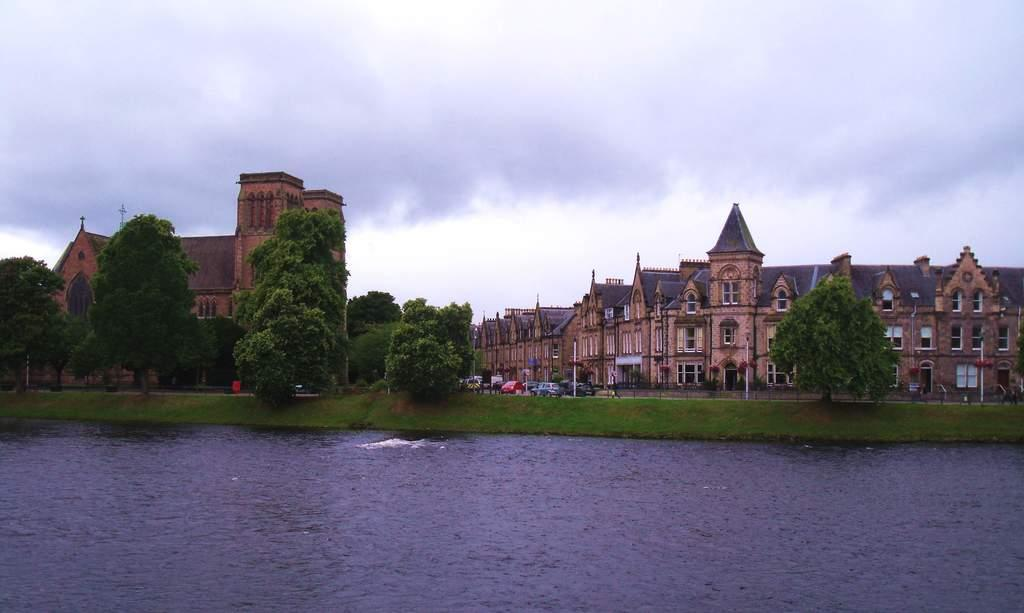What type of structures can be seen in the image? There are buildings in the image. What natural elements are present in the image? There are trees in the image. What man-made objects can be seen in the image? There are vehicles and poles in the image. What natural feature is visible in the image? There is water visible in the image. What can be seen in the background of the image? The sky is visible in the background of the image. How does the earthquake affect the art and love in the image? There is no earthquake, art, or love depicted in the image; it features buildings, trees, vehicles, poles, water, and the sky. 